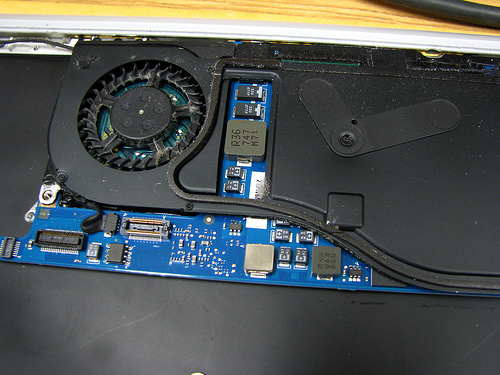<image>
Can you confirm if the fan is to the left of the circuit board? No. The fan is not to the left of the circuit board. From this viewpoint, they have a different horizontal relationship. 